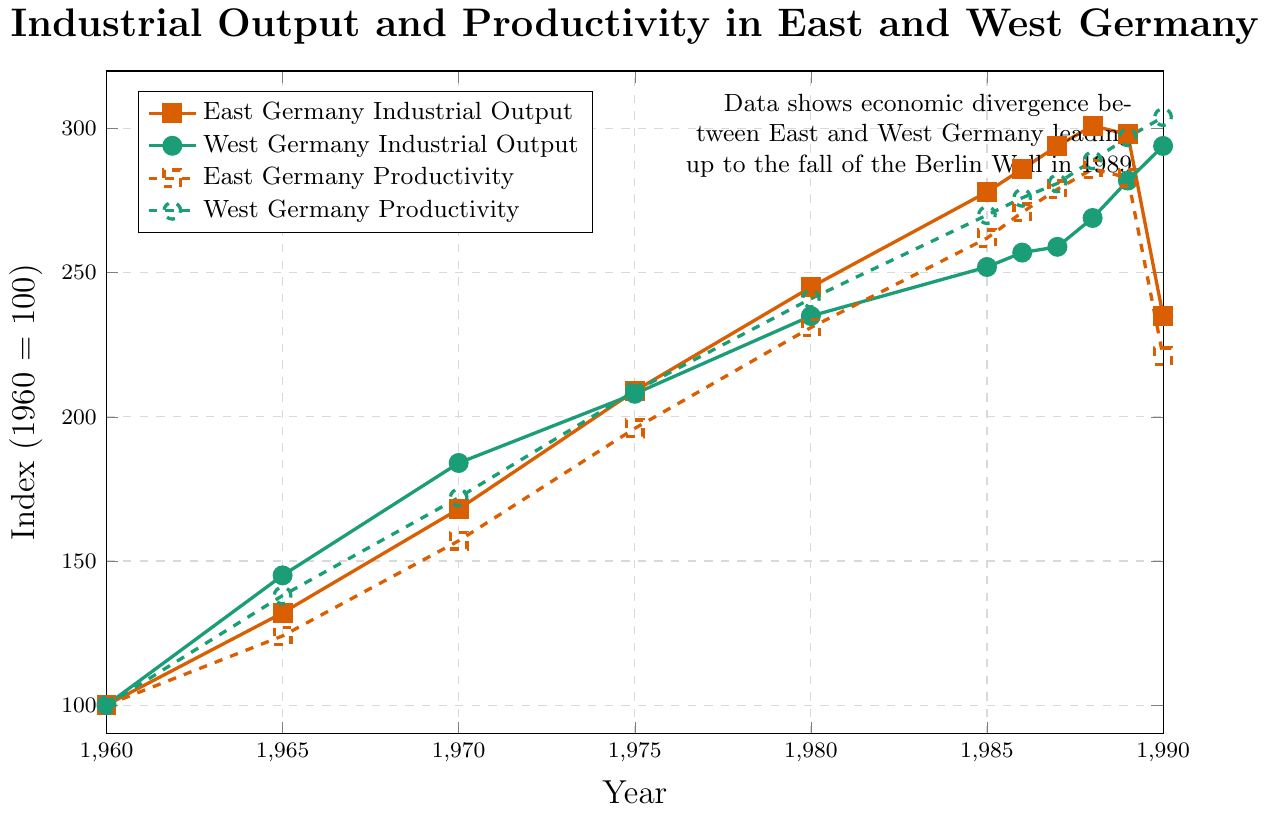What was the maximum industrial output index for West Germany? The maximum industrial output index for West Germany can be observed from the highest point on the green line representing West Germany's industrial output. By scanning the y-axis values, we see that the highest point is 294 in the year 1990.
Answer: 294 Which year saw the largest productivity gap between East and West Germany? To find the largest productivity gap, one needs to calculate the difference between East and West Germany's productivity for each year and identify the maximum. The gap can be calculated as follows: 1960 (0), 1965 (14), 1970 (15), 1975 (13), 1980 (10), 1985 (8), 1986 (5), 1987 (2), 1988 (3), 1989 (14), 1990 (83). The largest gap is in 1990, which is 83.
Answer: 1990 How did the industrial output trends of East and West Germany compare from 1980 to 1990? From the figure, observe both lines representing industrial output for East (orange) and West Germany (green). From 1980 to 1990, East Germany's output rose from 245 to 301 in 1988, then decreased sharply to 235 in 1990. West Germany's output shows a consistent increase from 235 in 1980 to 294 in 1990.
Answer: East Germany increased, then dropped; West Germany increased steadily By how much did East Germany's productivity index increase from 1960 to 1989? By subtracting the productivity index of East Germany in 1960 (100) from its index in 1989 (283), the increase is calculated as 283 - 100.
Answer: 183 Did East or West Germany ever experience a decline in industrial output from one year to the next during the given period? If yes, specify when. By examining both lines for any downward trends, we observe: East Germany's industrial output declined only from 1989 to 1990; West Germany's industrial output consistently rose, with no declines.
Answer: East Germany from 1989 to 1990 What was the productivity index of East Germany in 1985 and how does it compare to West Germany's productivity in the same year? The productivity index for East Germany in 1985 is 262 and for West Germany in the same year is 270. Comparing both values shows that West Germany had a higher productivity index by 8 points in 1985.
Answer: East Germany: 262, West Germany: 270, Gap: 8 In which year did West Germany's productivity index first exceed 250? To determine the year West Germany's productivity index first exceeded 250, trace the dashed green line and find the earliest point above 250. This occurs in 1985, where the index is 270.
Answer: 1985 How does the industrial output in East Germany in 1990 compare to its industrial output in 1980? Look for the points representing East Germany's industrial output on the solid orange line for 1980 (245) and 1990 (235). Comparing these values shows a decrease of 10 points.
Answer: Decrease by 10 What general trend can be observed in the productivity indices of East and West Germany from 1960 to 1990? By examining the dashed lines for both East (orange) and West Germany (green), both productivity indices show a general upward trend from 1960 to 1989. However, East Germany exhibits a decline in 1990, whereas West Germany's productivity continues to increase.
Answer: General increase, East declines in 1990 By how much did the industrial output of West Germany increase from 1960 to 1970 compared to East Germany's increase over the same period? Calculate the increase by subtracting 1960 values from 1970 for both regions. West Germany's increase: 184 - 100 = 84; East Germany's increase: 168 - 100 = 68. The difference in increases is 84 - 68.
Answer: 16 